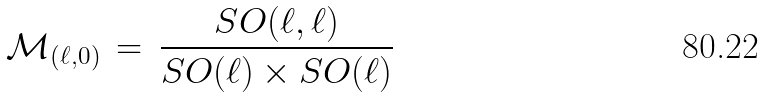<formula> <loc_0><loc_0><loc_500><loc_500>\mathcal { M } _ { ( \ell , 0 ) } \, = \, \frac { S O ( \ell , \ell ) } { S O ( \ell ) \times S O ( \ell ) }</formula> 